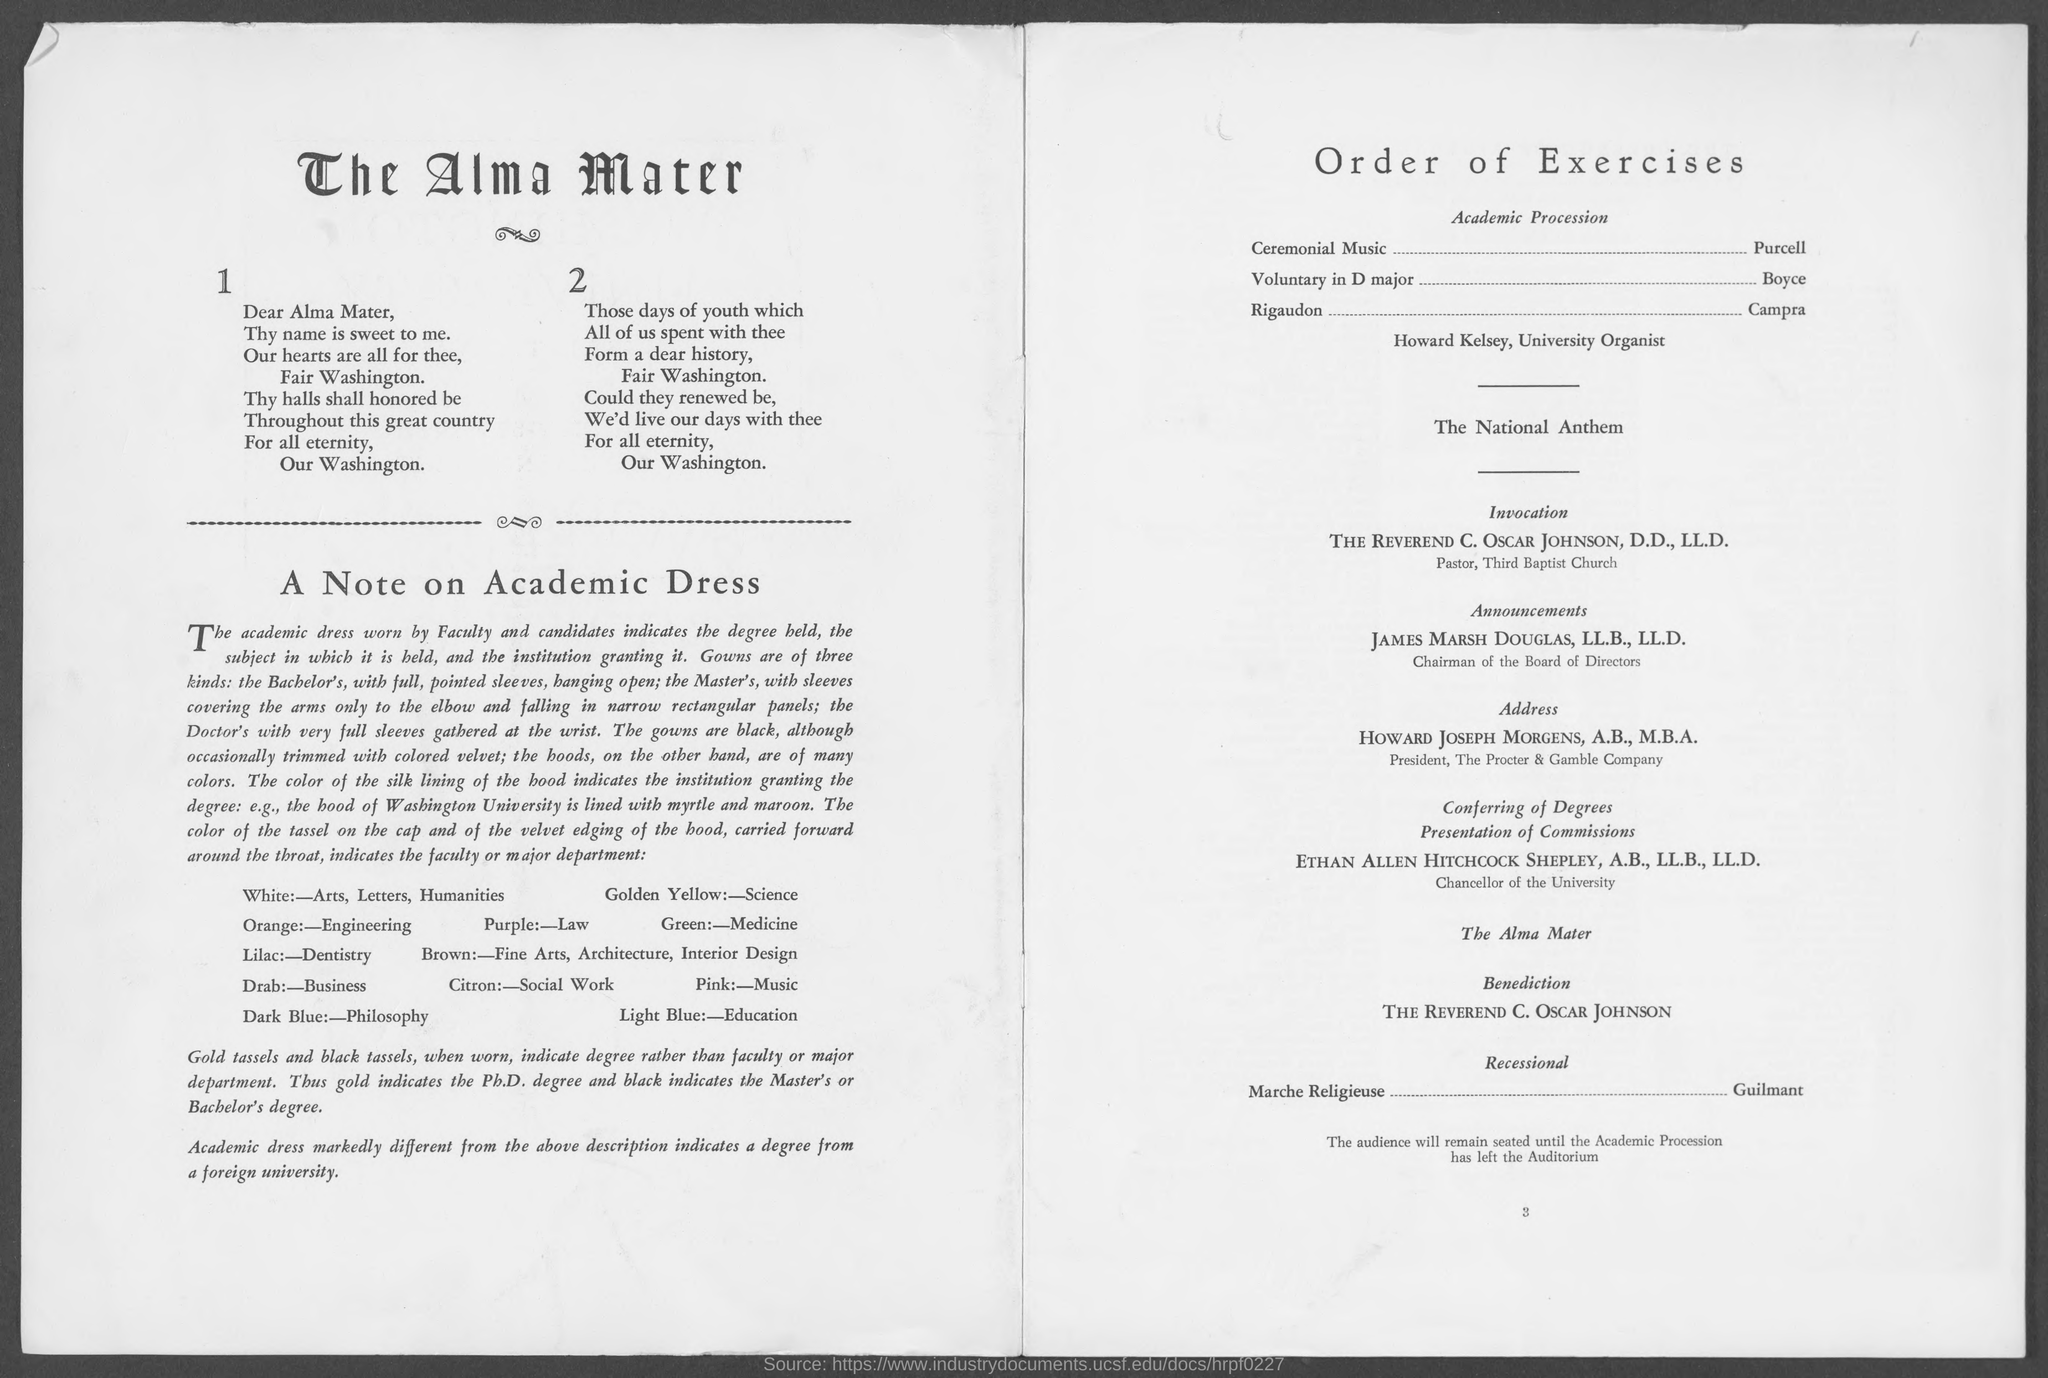Who is the Chairman of the Board of Directors?
Provide a short and direct response. James Marsh Douglas. What is the designation of HOWARD JOSEPH MORGENS, A.B., M.B.A.?
Your answer should be very brief. President, The Procter & Gamble Company. Who is the Pastor of Third Baptist Church?
Your response must be concise. THE REVEREND C. OSCAR JOHNSON, D.D., LL.D. 